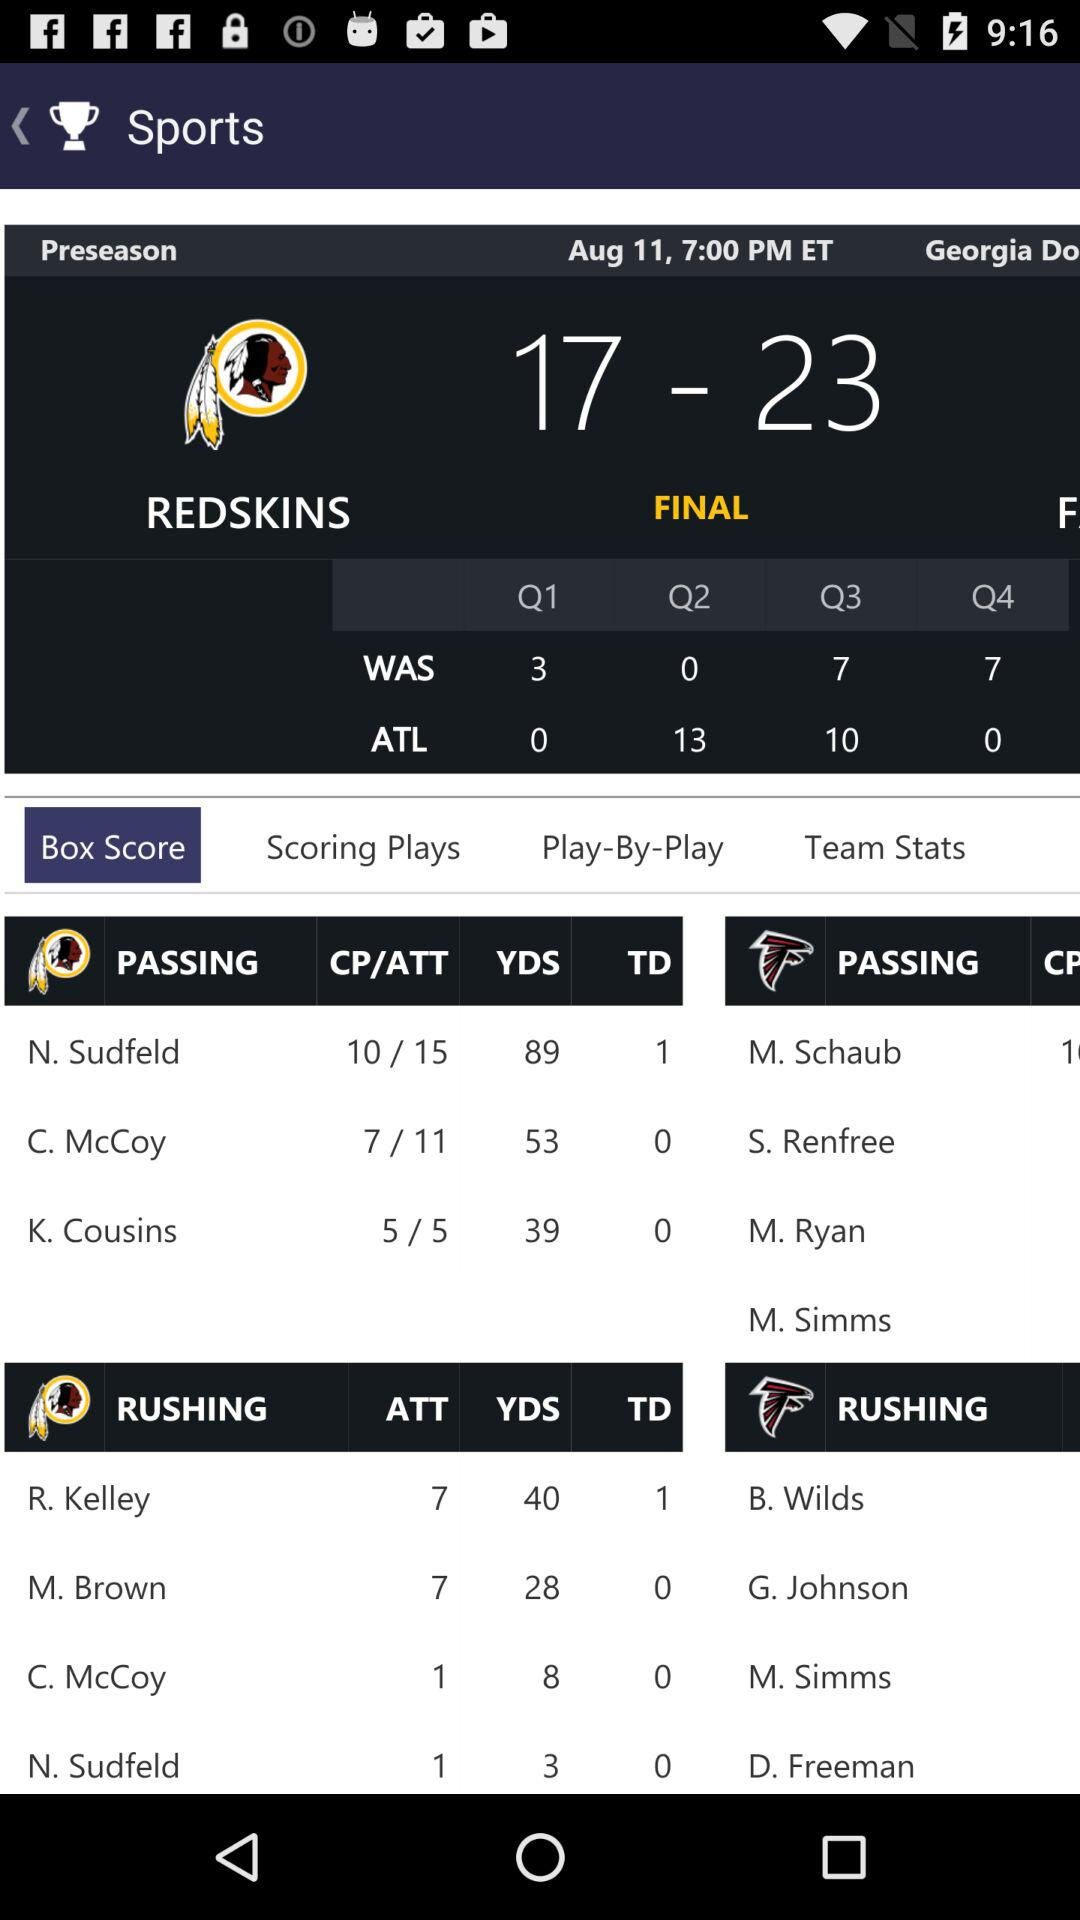What is the number of rushing yards for R. Kelley? The number of rushing yards for R. Kelley is 40. 